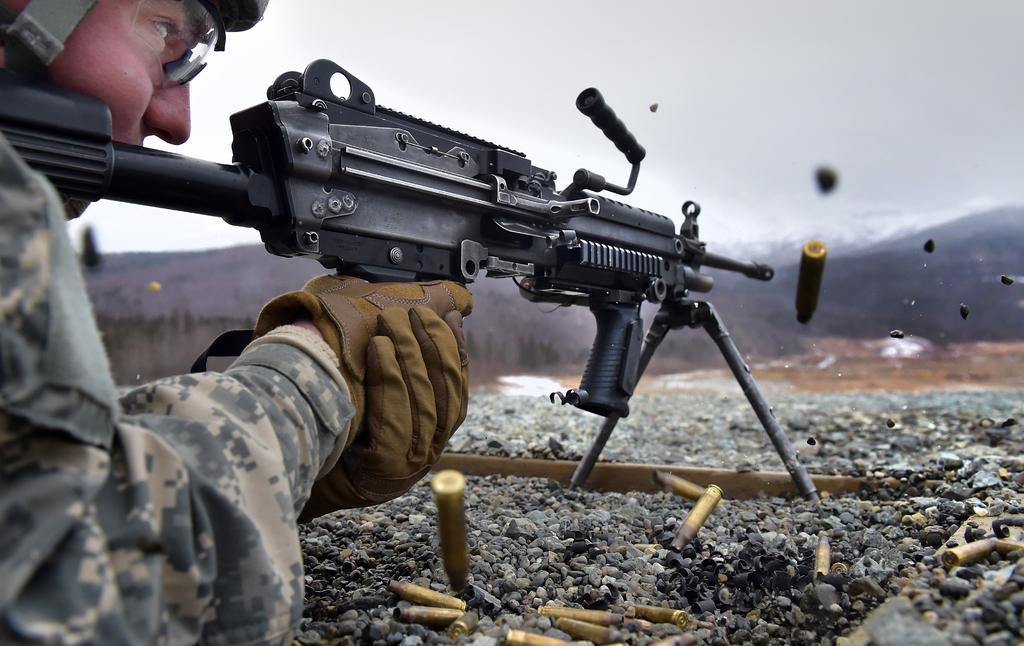Please provide a concise description of this image. In this image there is a person holding a gun. There are bullets. There are mountains. 